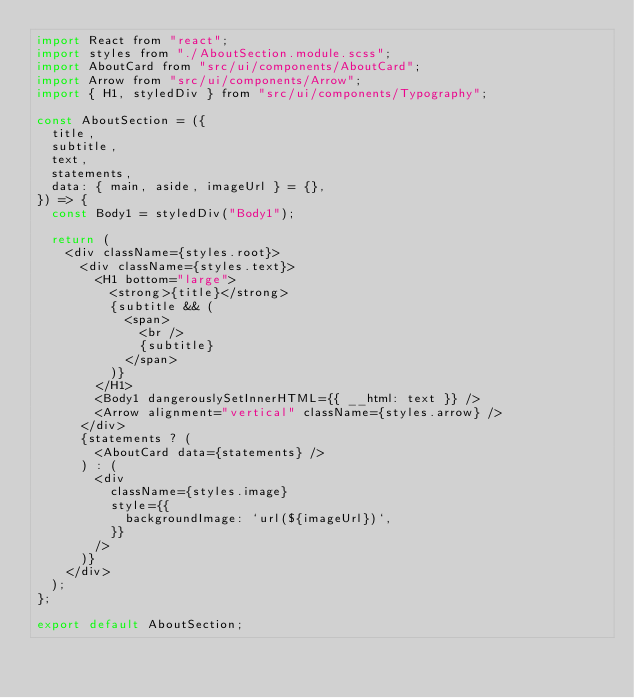Convert code to text. <code><loc_0><loc_0><loc_500><loc_500><_JavaScript_>import React from "react";
import styles from "./AboutSection.module.scss";
import AboutCard from "src/ui/components/AboutCard";
import Arrow from "src/ui/components/Arrow";
import { H1, styledDiv } from "src/ui/components/Typography";

const AboutSection = ({
  title,
  subtitle,
  text,
  statements,
  data: { main, aside, imageUrl } = {},
}) => {
  const Body1 = styledDiv("Body1");

  return (
    <div className={styles.root}>
      <div className={styles.text}>
        <H1 bottom="large">
          <strong>{title}</strong>
          {subtitle && (
            <span>
              <br />
              {subtitle}
            </span>
          )}
        </H1>
        <Body1 dangerouslySetInnerHTML={{ __html: text }} />
        <Arrow alignment="vertical" className={styles.arrow} />
      </div>
      {statements ? (
        <AboutCard data={statements} />
      ) : (
        <div
          className={styles.image}
          style={{
            backgroundImage: `url(${imageUrl})`,
          }}
        />
      )}
    </div>
  );
};

export default AboutSection;
</code> 